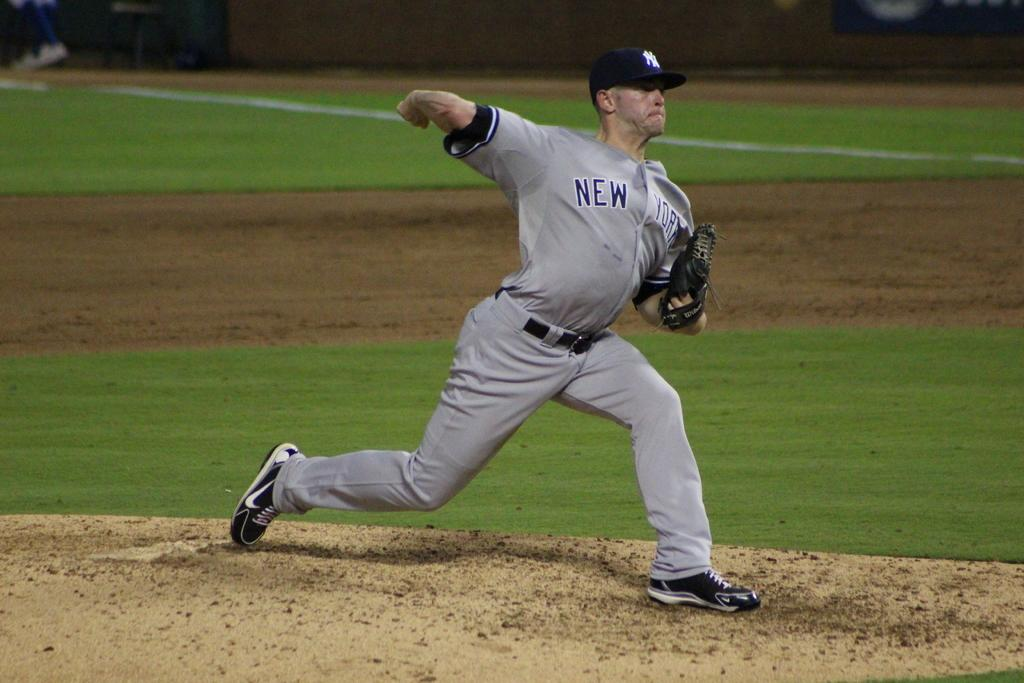<image>
Describe the image concisely. Pitcher pitching the ball with a gray uniform that says New York on the front. 